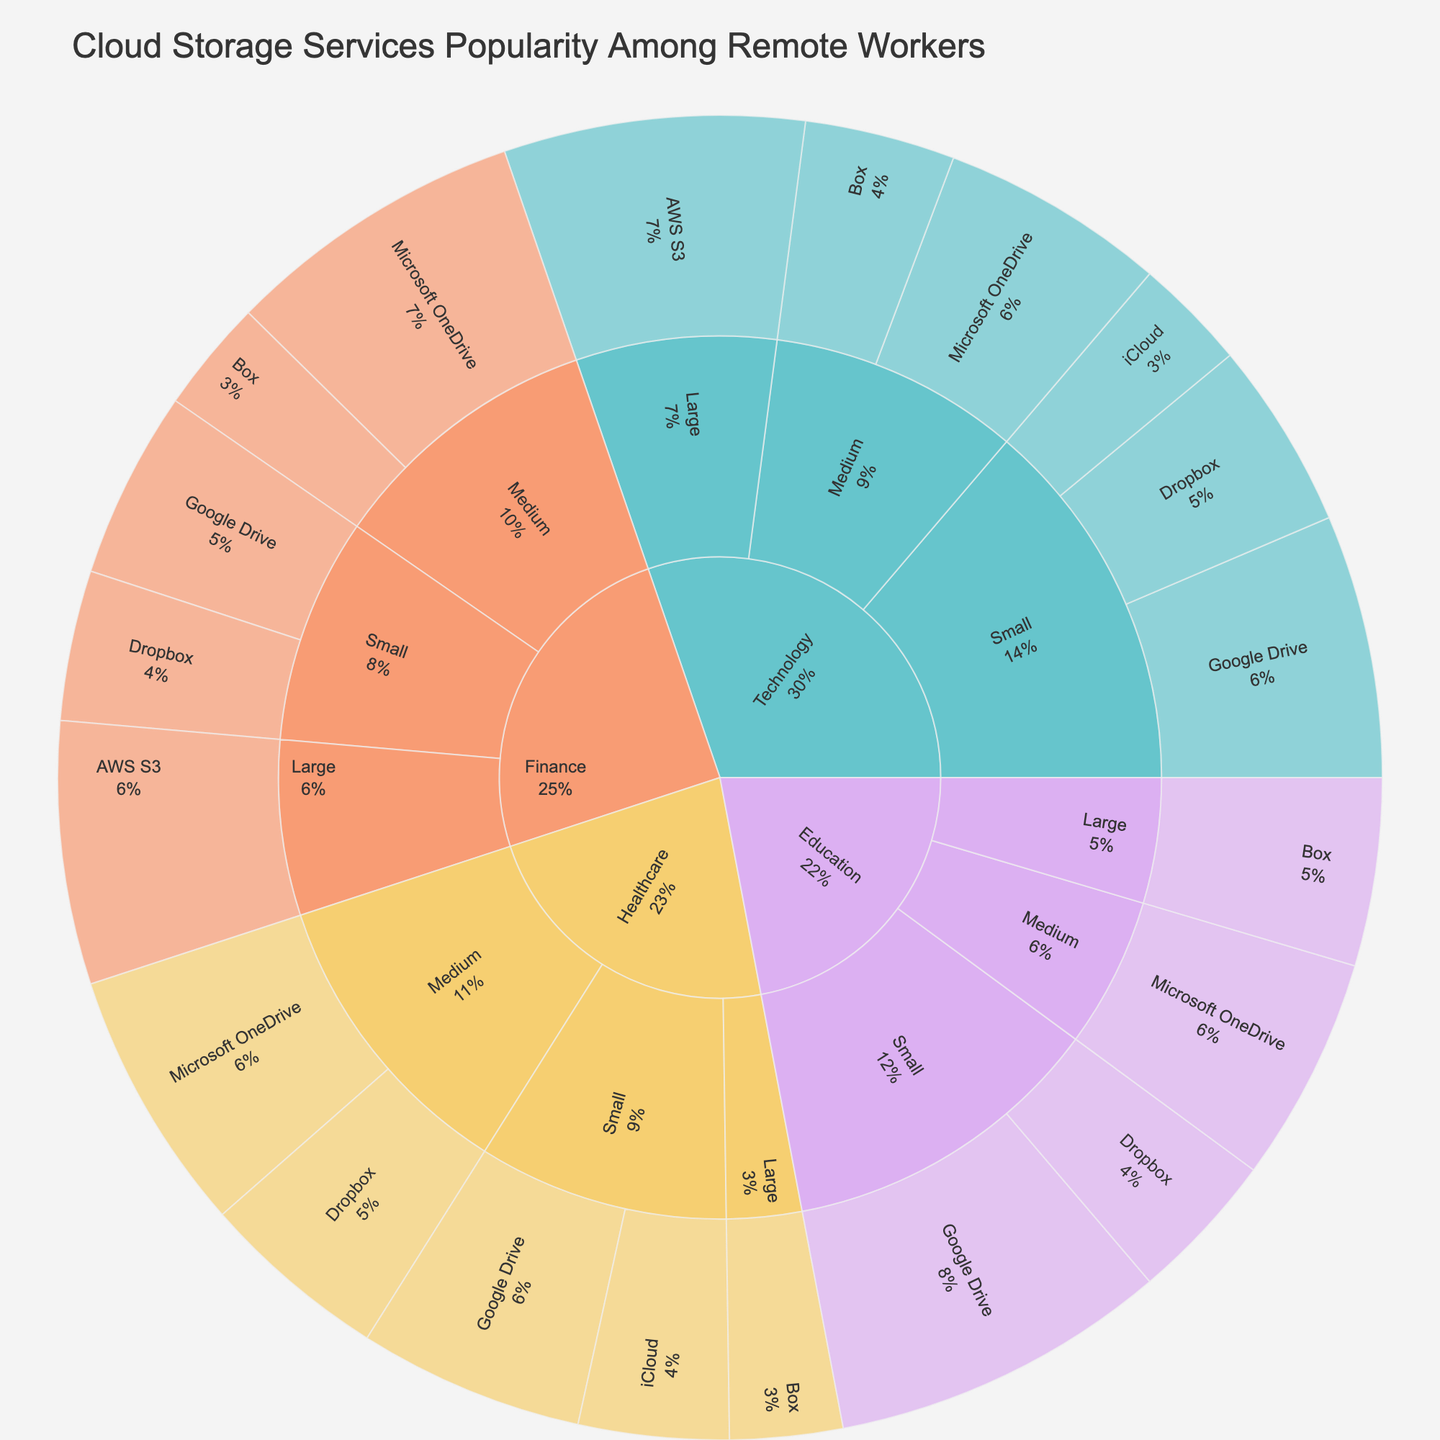What is the most popular cloud service among small technology companies? By looking at the Technology industry segment and identifying the 'Small' company size, the segment with the highest percentage can be identified as Google Drive with 35%.
Answer: Google Drive Which cloud service has the highest usage in the Healthcare industry for medium-sized companies? By examining the 'Healthcare' industry and 'Medium' company size segment, the cloud service with the highest percentage is Microsoft OneDrive with 35%.
Answer: Microsoft OneDrive What is the least popular cloud service among large companies in the Finance industry? Observing the 'Finance' industry segment and 'Large' company size, the cloud service with the smallest percentage is AWS S3 with 35%.
Answer: AWS S3 How does the popularity of Dropbox compare between small companies in technology and finance industries? By comparing the percentages for Dropbox in the 'Small' and 'Technology' (25%) and 'Small' and 'Finance' (20%) segments, Dropbox is more popular in small technology companies than in small finance companies.
Answer: Technology 25%, Finance 20% What percentage of medium-sized companies in the Education sector use Microsoft OneDrive? Navigate the plot to the 'Education' industry segment and then to the 'Medium' company size. Microsoft OneDrive is used by 30% of medium-sized companies in this sector.
Answer: 30% Which industry has the highest overall percentage usage of Google Drive for small companies? By reviewing the sunburst plot for the 'Small' company size in each industry, the 'Education' industry shows the highest percentage for Google Drive usage at 45%.
Answer: Education How does the usage of cloud services vary between small and large companies in the Technology industry? Compare the technology industry for 'Small' and 'Large' company sizes. Small companies use Dropbox (25%), Google Drive (35%), iCloud (15%). Large companies use AWS S3 (40%).
Answer: Small: Dropbox 25%, Google Drive 35%, iCloud 15%; Large: AWS S3 40% What is the combined percentage of usage for Dropbox and Box among medium-sized healthcare companies? Observe the 'Healthcare' industry with 'Medium' company size. Summing up Dropbox (25%) and Box (35%) results in a total of 60%.
Answer: 60% Which cloud service is used by 25% of large companies in the Education industry? Drill down into the 'Education' industry and 'Large' company size; Box is used by 25% of large companies.
Answer: Box Across all industries, which cloud service appears to be the most popular? Summing all percentages in each segment, Google Drive appears often with the highest individual segment percentages (Technology Small 35%, Healthcare Small 30%, Finance Small 25%, Education Small 45%).
Answer: Google Drive 